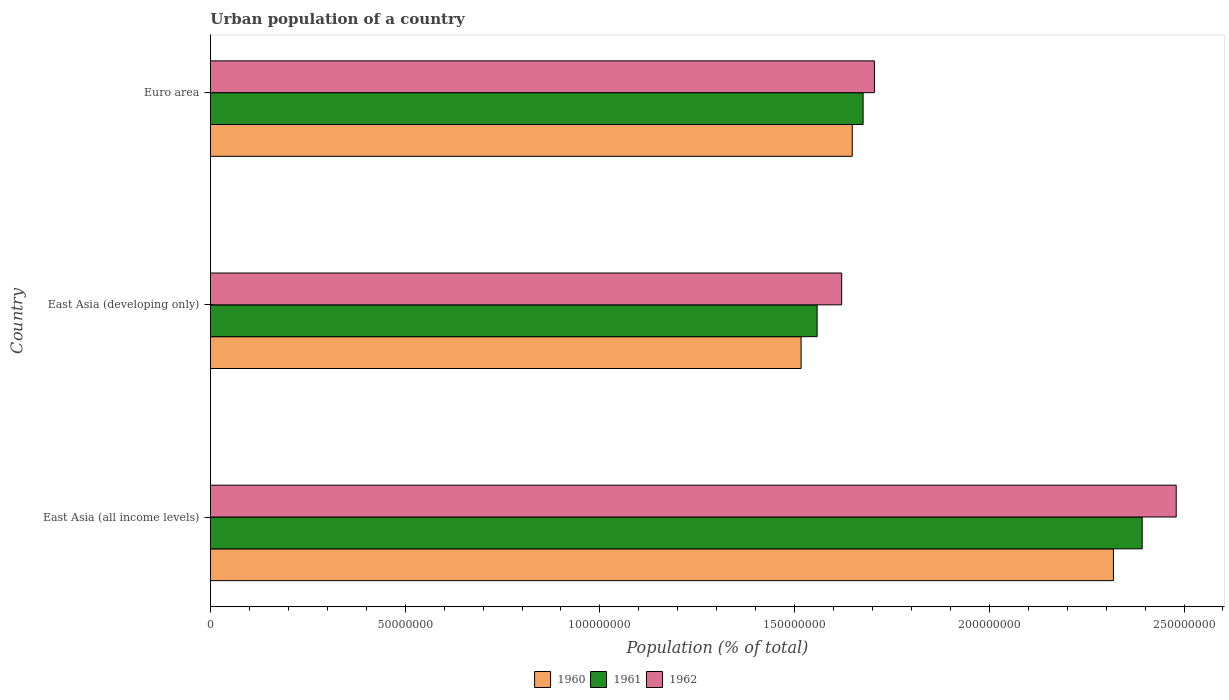What is the urban population in 1961 in East Asia (developing only)?
Offer a terse response. 1.56e+08. Across all countries, what is the maximum urban population in 1962?
Provide a succinct answer. 2.48e+08. Across all countries, what is the minimum urban population in 1962?
Provide a short and direct response. 1.62e+08. In which country was the urban population in 1961 maximum?
Ensure brevity in your answer.  East Asia (all income levels). In which country was the urban population in 1961 minimum?
Keep it short and to the point. East Asia (developing only). What is the total urban population in 1960 in the graph?
Your answer should be very brief. 5.48e+08. What is the difference between the urban population in 1960 in East Asia (all income levels) and that in Euro area?
Offer a very short reply. 6.71e+07. What is the difference between the urban population in 1960 in Euro area and the urban population in 1962 in East Asia (developing only)?
Your answer should be very brief. 2.72e+06. What is the average urban population in 1960 per country?
Offer a terse response. 1.83e+08. What is the difference between the urban population in 1961 and urban population in 1960 in Euro area?
Provide a short and direct response. 2.79e+06. What is the ratio of the urban population in 1962 in East Asia (all income levels) to that in East Asia (developing only)?
Offer a terse response. 1.53. What is the difference between the highest and the second highest urban population in 1961?
Your answer should be compact. 7.17e+07. What is the difference between the highest and the lowest urban population in 1962?
Offer a terse response. 8.59e+07. How many bars are there?
Give a very brief answer. 9. Are the values on the major ticks of X-axis written in scientific E-notation?
Give a very brief answer. No. What is the title of the graph?
Your answer should be compact. Urban population of a country. What is the label or title of the X-axis?
Offer a terse response. Population (% of total). What is the label or title of the Y-axis?
Ensure brevity in your answer.  Country. What is the Population (% of total) in 1960 in East Asia (all income levels)?
Offer a very short reply. 2.32e+08. What is the Population (% of total) of 1961 in East Asia (all income levels)?
Give a very brief answer. 2.39e+08. What is the Population (% of total) in 1962 in East Asia (all income levels)?
Keep it short and to the point. 2.48e+08. What is the Population (% of total) in 1960 in East Asia (developing only)?
Your response must be concise. 1.52e+08. What is the Population (% of total) in 1961 in East Asia (developing only)?
Provide a succinct answer. 1.56e+08. What is the Population (% of total) in 1962 in East Asia (developing only)?
Keep it short and to the point. 1.62e+08. What is the Population (% of total) in 1960 in Euro area?
Your response must be concise. 1.65e+08. What is the Population (% of total) in 1961 in Euro area?
Give a very brief answer. 1.68e+08. What is the Population (% of total) in 1962 in Euro area?
Keep it short and to the point. 1.70e+08. Across all countries, what is the maximum Population (% of total) of 1960?
Provide a succinct answer. 2.32e+08. Across all countries, what is the maximum Population (% of total) in 1961?
Offer a very short reply. 2.39e+08. Across all countries, what is the maximum Population (% of total) in 1962?
Provide a short and direct response. 2.48e+08. Across all countries, what is the minimum Population (% of total) of 1960?
Make the answer very short. 1.52e+08. Across all countries, what is the minimum Population (% of total) of 1961?
Give a very brief answer. 1.56e+08. Across all countries, what is the minimum Population (% of total) of 1962?
Keep it short and to the point. 1.62e+08. What is the total Population (% of total) of 1960 in the graph?
Ensure brevity in your answer.  5.48e+08. What is the total Population (% of total) of 1961 in the graph?
Provide a short and direct response. 5.63e+08. What is the total Population (% of total) in 1962 in the graph?
Your answer should be compact. 5.81e+08. What is the difference between the Population (% of total) of 1960 in East Asia (all income levels) and that in East Asia (developing only)?
Ensure brevity in your answer.  8.02e+07. What is the difference between the Population (% of total) in 1961 in East Asia (all income levels) and that in East Asia (developing only)?
Offer a very short reply. 8.35e+07. What is the difference between the Population (% of total) in 1962 in East Asia (all income levels) and that in East Asia (developing only)?
Ensure brevity in your answer.  8.59e+07. What is the difference between the Population (% of total) of 1960 in East Asia (all income levels) and that in Euro area?
Offer a terse response. 6.71e+07. What is the difference between the Population (% of total) of 1961 in East Asia (all income levels) and that in Euro area?
Keep it short and to the point. 7.17e+07. What is the difference between the Population (% of total) of 1962 in East Asia (all income levels) and that in Euro area?
Your response must be concise. 7.75e+07. What is the difference between the Population (% of total) in 1960 in East Asia (developing only) and that in Euro area?
Your answer should be very brief. -1.31e+07. What is the difference between the Population (% of total) in 1961 in East Asia (developing only) and that in Euro area?
Offer a very short reply. -1.18e+07. What is the difference between the Population (% of total) in 1962 in East Asia (developing only) and that in Euro area?
Offer a very short reply. -8.40e+06. What is the difference between the Population (% of total) of 1960 in East Asia (all income levels) and the Population (% of total) of 1961 in East Asia (developing only)?
Your answer should be compact. 7.61e+07. What is the difference between the Population (% of total) in 1960 in East Asia (all income levels) and the Population (% of total) in 1962 in East Asia (developing only)?
Your response must be concise. 6.98e+07. What is the difference between the Population (% of total) in 1961 in East Asia (all income levels) and the Population (% of total) in 1962 in East Asia (developing only)?
Offer a terse response. 7.72e+07. What is the difference between the Population (% of total) of 1960 in East Asia (all income levels) and the Population (% of total) of 1961 in Euro area?
Offer a terse response. 6.43e+07. What is the difference between the Population (% of total) in 1960 in East Asia (all income levels) and the Population (% of total) in 1962 in Euro area?
Make the answer very short. 6.14e+07. What is the difference between the Population (% of total) of 1961 in East Asia (all income levels) and the Population (% of total) of 1962 in Euro area?
Provide a short and direct response. 6.88e+07. What is the difference between the Population (% of total) in 1960 in East Asia (developing only) and the Population (% of total) in 1961 in Euro area?
Keep it short and to the point. -1.59e+07. What is the difference between the Population (% of total) in 1960 in East Asia (developing only) and the Population (% of total) in 1962 in Euro area?
Your response must be concise. -1.88e+07. What is the difference between the Population (% of total) of 1961 in East Asia (developing only) and the Population (% of total) of 1962 in Euro area?
Give a very brief answer. -1.47e+07. What is the average Population (% of total) in 1960 per country?
Your answer should be very brief. 1.83e+08. What is the average Population (% of total) in 1961 per country?
Your response must be concise. 1.88e+08. What is the average Population (% of total) in 1962 per country?
Provide a short and direct response. 1.94e+08. What is the difference between the Population (% of total) of 1960 and Population (% of total) of 1961 in East Asia (all income levels)?
Give a very brief answer. -7.39e+06. What is the difference between the Population (% of total) in 1960 and Population (% of total) in 1962 in East Asia (all income levels)?
Give a very brief answer. -1.61e+07. What is the difference between the Population (% of total) in 1961 and Population (% of total) in 1962 in East Asia (all income levels)?
Provide a succinct answer. -8.73e+06. What is the difference between the Population (% of total) in 1960 and Population (% of total) in 1961 in East Asia (developing only)?
Make the answer very short. -4.12e+06. What is the difference between the Population (% of total) of 1960 and Population (% of total) of 1962 in East Asia (developing only)?
Give a very brief answer. -1.04e+07. What is the difference between the Population (% of total) in 1961 and Population (% of total) in 1962 in East Asia (developing only)?
Offer a terse response. -6.30e+06. What is the difference between the Population (% of total) in 1960 and Population (% of total) in 1961 in Euro area?
Your answer should be very brief. -2.79e+06. What is the difference between the Population (% of total) in 1960 and Population (% of total) in 1962 in Euro area?
Give a very brief answer. -5.69e+06. What is the difference between the Population (% of total) of 1961 and Population (% of total) of 1962 in Euro area?
Provide a short and direct response. -2.90e+06. What is the ratio of the Population (% of total) of 1960 in East Asia (all income levels) to that in East Asia (developing only)?
Provide a short and direct response. 1.53. What is the ratio of the Population (% of total) of 1961 in East Asia (all income levels) to that in East Asia (developing only)?
Offer a terse response. 1.54. What is the ratio of the Population (% of total) of 1962 in East Asia (all income levels) to that in East Asia (developing only)?
Your answer should be compact. 1.53. What is the ratio of the Population (% of total) in 1960 in East Asia (all income levels) to that in Euro area?
Make the answer very short. 1.41. What is the ratio of the Population (% of total) of 1961 in East Asia (all income levels) to that in Euro area?
Make the answer very short. 1.43. What is the ratio of the Population (% of total) of 1962 in East Asia (all income levels) to that in Euro area?
Give a very brief answer. 1.45. What is the ratio of the Population (% of total) of 1960 in East Asia (developing only) to that in Euro area?
Your response must be concise. 0.92. What is the ratio of the Population (% of total) of 1961 in East Asia (developing only) to that in Euro area?
Offer a terse response. 0.93. What is the ratio of the Population (% of total) of 1962 in East Asia (developing only) to that in Euro area?
Your answer should be very brief. 0.95. What is the difference between the highest and the second highest Population (% of total) of 1960?
Offer a very short reply. 6.71e+07. What is the difference between the highest and the second highest Population (% of total) in 1961?
Provide a succinct answer. 7.17e+07. What is the difference between the highest and the second highest Population (% of total) of 1962?
Your answer should be compact. 7.75e+07. What is the difference between the highest and the lowest Population (% of total) in 1960?
Your response must be concise. 8.02e+07. What is the difference between the highest and the lowest Population (% of total) in 1961?
Keep it short and to the point. 8.35e+07. What is the difference between the highest and the lowest Population (% of total) in 1962?
Give a very brief answer. 8.59e+07. 